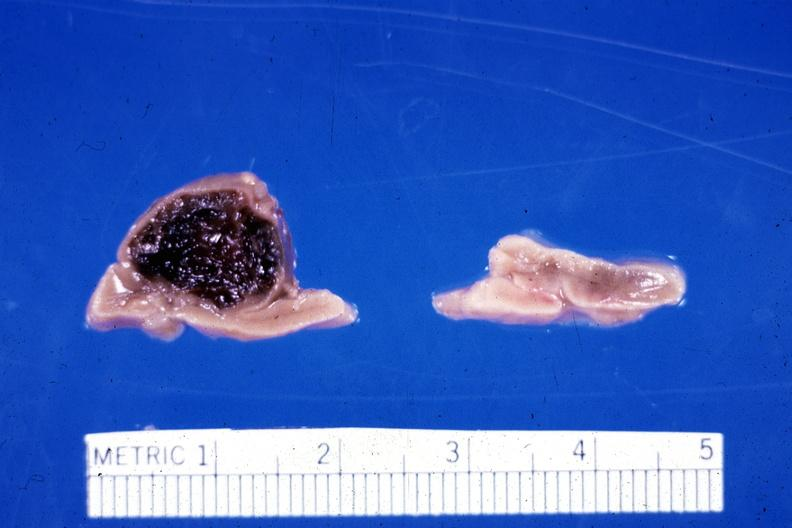where does this belong to?
Answer the question using a single word or phrase. Endocrine system 